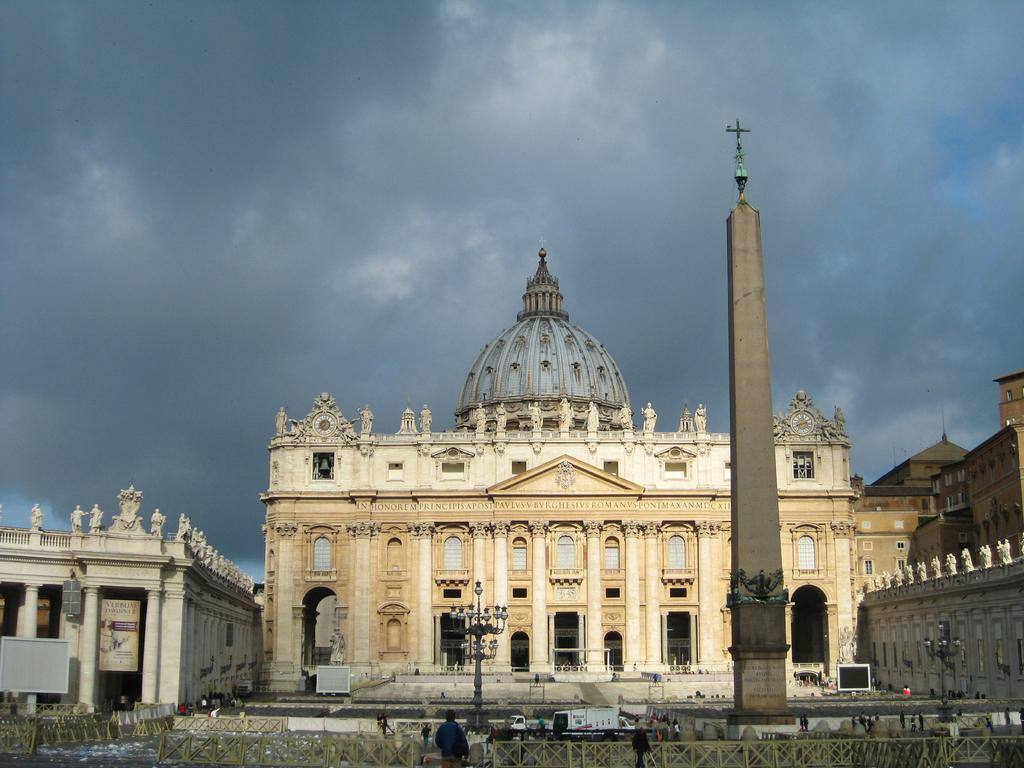What type of structures can be seen in the image? There are buildings in the image. What is the condition of the sky in the image? The sky is cloudy in the image. Who or what is present in the image besides the buildings? There are people and lamps in the image. What type of landmark is visible in the image? There is a tomb in the image. What type of liquid can be seen flowing from the lamps in the image? There is no liquid flowing from the lamps in the image; they are stationary. What color is the paint on the tomb in the image? There is no mention of paint on the tomb in the image, so we cannot determine its color. 